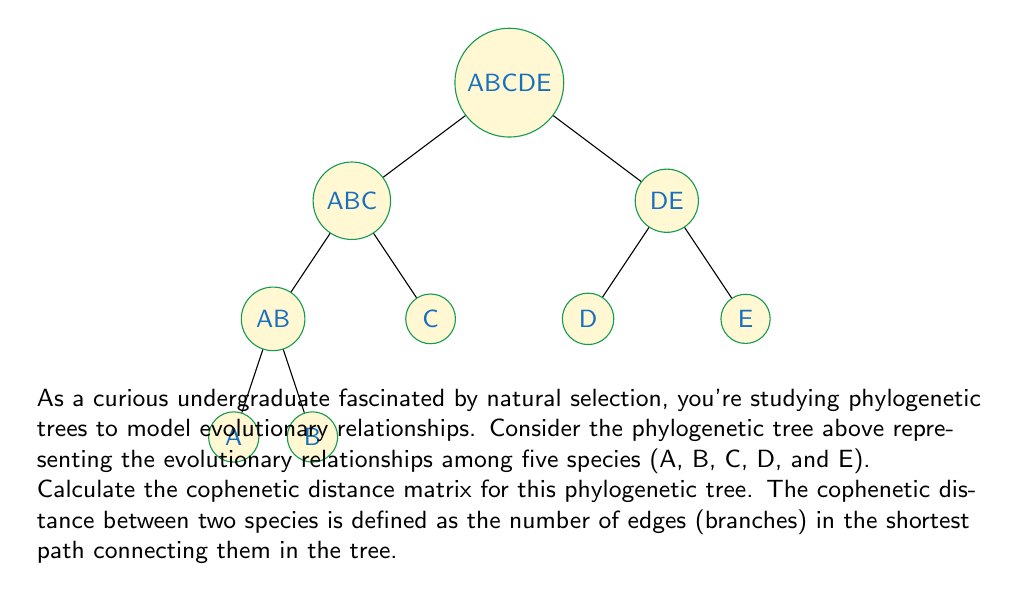What is the answer to this math problem? To calculate the cophenetic distance matrix, we need to determine the distance between each pair of species in the phylogenetic tree. Let's go through this step-by-step:

1) First, let's count the edges between each pair of species:

   A-B: 2 edges (A to AB, AB to B)
   A-C: 4 edges (A to AB, AB to ABC, ABC to CD, CD to C)
   A-D: 4 edges (A to AB, AB to ABC, ABC to CD, CD to D)
   A-E: 5 edges (A to AB, AB to ABC, ABC to ABCDE, ABCDE to E)
   B-C: 4 edges (B to AB, AB to ABC, ABC to CD, CD to C)
   B-D: 4 edges (B to AB, AB to ABC, ABC to CD, CD to D)
   B-E: 5 edges (B to AB, AB to ABC, ABC to ABCDE, ABCDE to E)
   C-D: 2 edges (C to CD, CD to D)
   C-E: 3 edges (C to CD, CD to ABC, ABC to ABCDE, ABCDE to E)
   D-E: 3 edges (D to CD, CD to ABC, ABC to ABCDE, ABCDE to E)

2) Now, we can construct the cophenetic distance matrix. This will be a symmetric 5x5 matrix where the entry in row i and column j represents the cophenetic distance between species i and j.

3) The matrix will look like this:

   $$
   \begin{bmatrix}
   0 & 2 & 4 & 4 & 5 \\
   2 & 0 & 4 & 4 & 5 \\
   4 & 4 & 0 & 2 & 3 \\
   4 & 4 & 2 & 0 & 3 \\
   5 & 5 & 3 & 3 & 0
   \end{bmatrix}
   $$

   where the rows and columns represent species A, B, C, D, and E in that order.

4) Note that the diagonal elements are all 0 (distance from a species to itself), and the matrix is symmetric (distance from A to B is the same as B to A).
Answer: $$
\begin{bmatrix}
0 & 2 & 4 & 4 & 5 \\
2 & 0 & 4 & 4 & 5 \\
4 & 4 & 0 & 2 & 3 \\
4 & 4 & 2 & 0 & 3 \\
5 & 5 & 3 & 3 & 0
\end{bmatrix}
$$ 